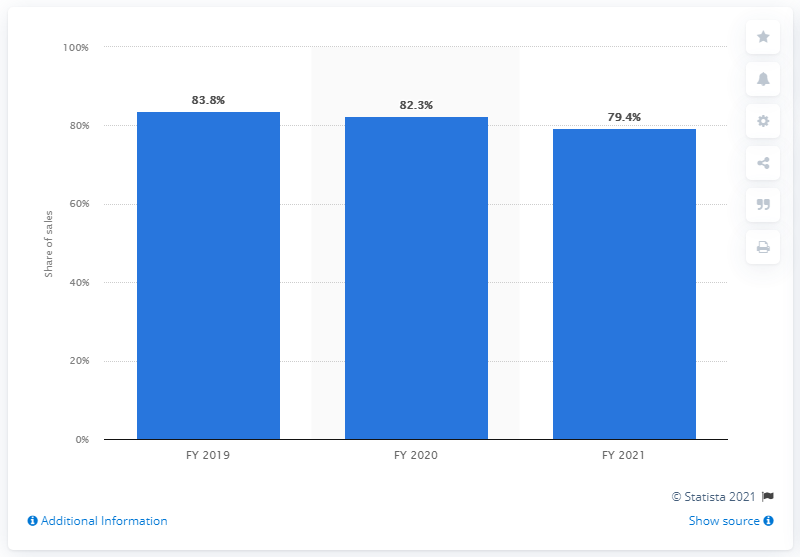Point out several critical features in this image. In the fiscal year ending March 2021, games published by Nintendo accounted for 79.4% of dedicated video game platform software sales. 